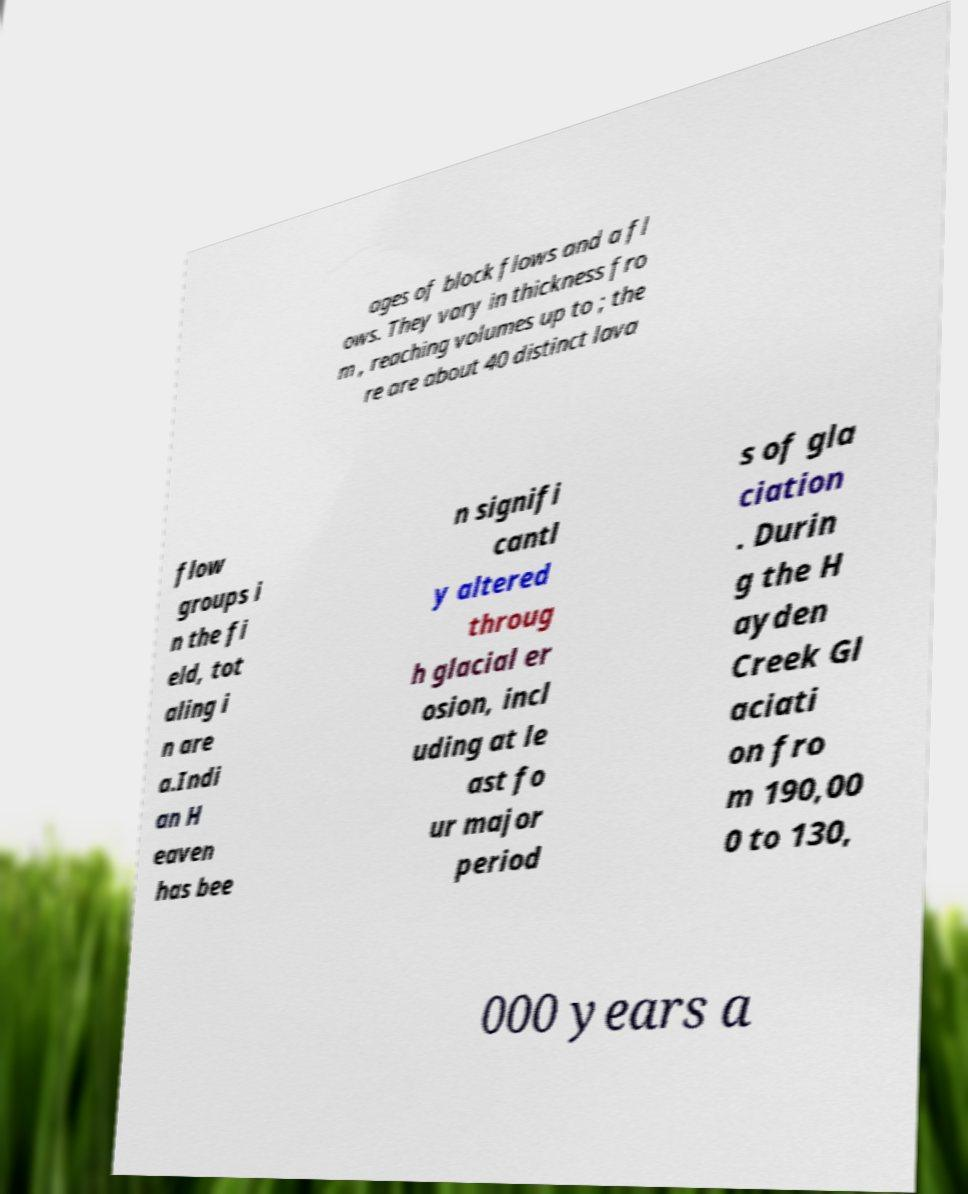I need the written content from this picture converted into text. Can you do that? ages of block flows and a fl ows. They vary in thickness fro m , reaching volumes up to ; the re are about 40 distinct lava flow groups i n the fi eld, tot aling i n are a.Indi an H eaven has bee n signifi cantl y altered throug h glacial er osion, incl uding at le ast fo ur major period s of gla ciation . Durin g the H ayden Creek Gl aciati on fro m 190,00 0 to 130, 000 years a 